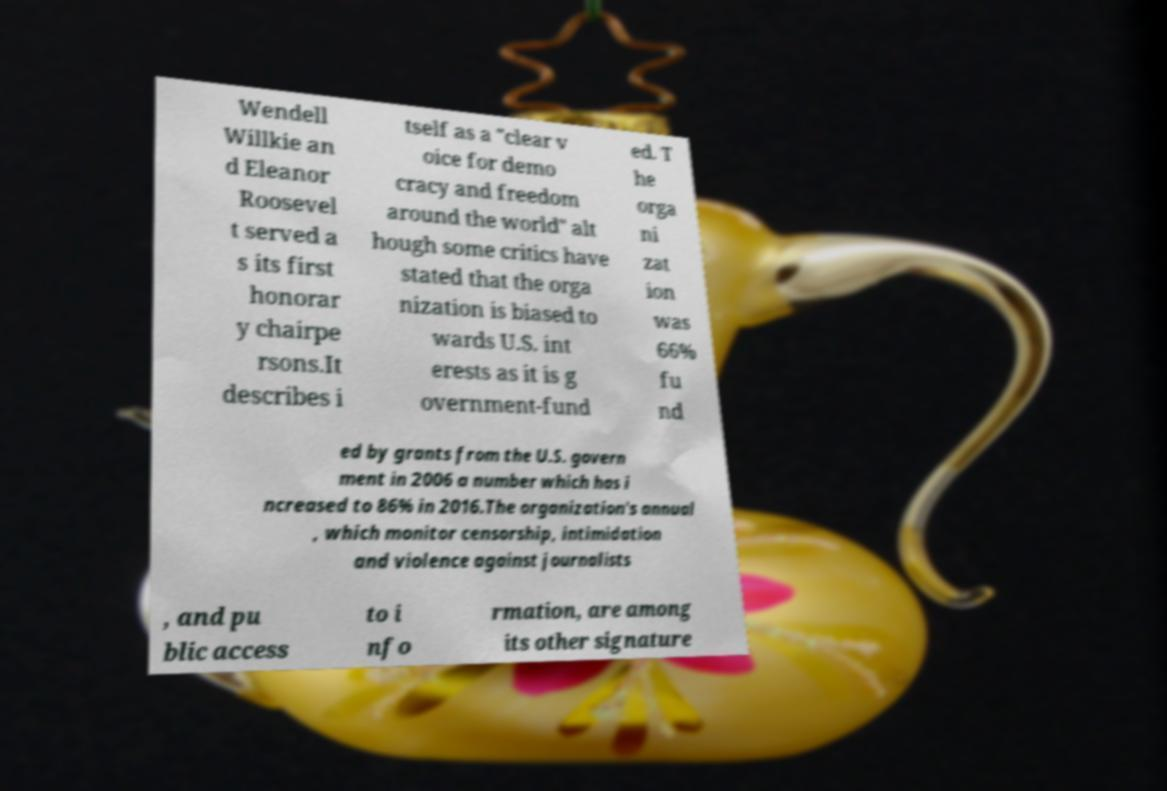There's text embedded in this image that I need extracted. Can you transcribe it verbatim? Wendell Willkie an d Eleanor Roosevel t served a s its first honorar y chairpe rsons.It describes i tself as a "clear v oice for demo cracy and freedom around the world" alt hough some critics have stated that the orga nization is biased to wards U.S. int erests as it is g overnment-fund ed. T he orga ni zat ion was 66% fu nd ed by grants from the U.S. govern ment in 2006 a number which has i ncreased to 86% in 2016.The organization's annual , which monitor censorship, intimidation and violence against journalists , and pu blic access to i nfo rmation, are among its other signature 